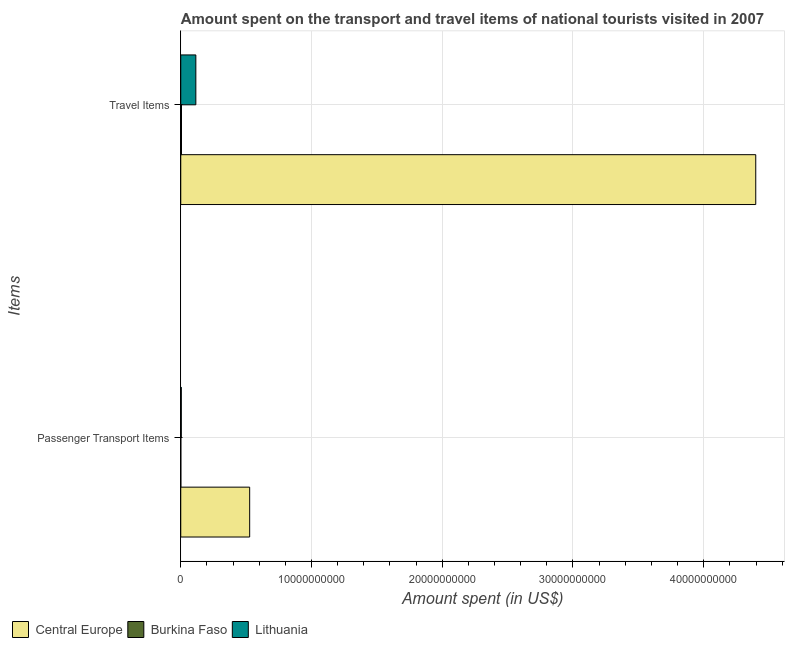How many different coloured bars are there?
Your answer should be very brief. 3. How many groups of bars are there?
Provide a succinct answer. 2. Are the number of bars per tick equal to the number of legend labels?
Provide a short and direct response. Yes. Are the number of bars on each tick of the Y-axis equal?
Make the answer very short. Yes. How many bars are there on the 1st tick from the top?
Offer a terse response. 3. How many bars are there on the 1st tick from the bottom?
Provide a succinct answer. 3. What is the label of the 2nd group of bars from the top?
Offer a terse response. Passenger Transport Items. What is the amount spent on passenger transport items in Burkina Faso?
Offer a terse response. 5.00e+06. Across all countries, what is the maximum amount spent in travel items?
Keep it short and to the point. 4.40e+1. Across all countries, what is the minimum amount spent on passenger transport items?
Ensure brevity in your answer.  5.00e+06. In which country was the amount spent in travel items maximum?
Your answer should be very brief. Central Europe. In which country was the amount spent in travel items minimum?
Provide a short and direct response. Burkina Faso. What is the total amount spent in travel items in the graph?
Your answer should be very brief. 4.52e+1. What is the difference between the amount spent on passenger transport items in Lithuania and that in Central Europe?
Offer a very short reply. -5.23e+09. What is the difference between the amount spent in travel items in Central Europe and the amount spent on passenger transport items in Burkina Faso?
Provide a succinct answer. 4.40e+1. What is the average amount spent in travel items per country?
Offer a very short reply. 1.51e+1. What is the difference between the amount spent in travel items and amount spent on passenger transport items in Lithuania?
Give a very brief answer. 1.11e+09. What is the ratio of the amount spent on passenger transport items in Burkina Faso to that in Central Europe?
Your response must be concise. 0. Is the amount spent in travel items in Lithuania less than that in Burkina Faso?
Offer a very short reply. No. In how many countries, is the amount spent on passenger transport items greater than the average amount spent on passenger transport items taken over all countries?
Keep it short and to the point. 1. What does the 2nd bar from the top in Travel Items represents?
Keep it short and to the point. Burkina Faso. What does the 1st bar from the bottom in Travel Items represents?
Give a very brief answer. Central Europe. How many bars are there?
Offer a terse response. 6. What is the difference between two consecutive major ticks on the X-axis?
Your answer should be compact. 1.00e+1. Are the values on the major ticks of X-axis written in scientific E-notation?
Your response must be concise. No. Does the graph contain any zero values?
Provide a short and direct response. No. Where does the legend appear in the graph?
Ensure brevity in your answer.  Bottom left. How many legend labels are there?
Provide a succinct answer. 3. How are the legend labels stacked?
Make the answer very short. Horizontal. What is the title of the graph?
Offer a terse response. Amount spent on the transport and travel items of national tourists visited in 2007. Does "Denmark" appear as one of the legend labels in the graph?
Provide a succinct answer. No. What is the label or title of the X-axis?
Your response must be concise. Amount spent (in US$). What is the label or title of the Y-axis?
Make the answer very short. Items. What is the Amount spent (in US$) of Central Europe in Passenger Transport Items?
Make the answer very short. 5.27e+09. What is the Amount spent (in US$) in Lithuania in Passenger Transport Items?
Your answer should be compact. 3.90e+07. What is the Amount spent (in US$) in Central Europe in Travel Items?
Give a very brief answer. 4.40e+1. What is the Amount spent (in US$) of Burkina Faso in Travel Items?
Keep it short and to the point. 5.60e+07. What is the Amount spent (in US$) of Lithuania in Travel Items?
Your answer should be compact. 1.15e+09. Across all Items, what is the maximum Amount spent (in US$) of Central Europe?
Offer a very short reply. 4.40e+1. Across all Items, what is the maximum Amount spent (in US$) in Burkina Faso?
Ensure brevity in your answer.  5.60e+07. Across all Items, what is the maximum Amount spent (in US$) of Lithuania?
Keep it short and to the point. 1.15e+09. Across all Items, what is the minimum Amount spent (in US$) in Central Europe?
Provide a short and direct response. 5.27e+09. Across all Items, what is the minimum Amount spent (in US$) of Lithuania?
Ensure brevity in your answer.  3.90e+07. What is the total Amount spent (in US$) in Central Europe in the graph?
Offer a terse response. 4.92e+1. What is the total Amount spent (in US$) in Burkina Faso in the graph?
Give a very brief answer. 6.10e+07. What is the total Amount spent (in US$) of Lithuania in the graph?
Make the answer very short. 1.19e+09. What is the difference between the Amount spent (in US$) in Central Europe in Passenger Transport Items and that in Travel Items?
Ensure brevity in your answer.  -3.87e+1. What is the difference between the Amount spent (in US$) of Burkina Faso in Passenger Transport Items and that in Travel Items?
Your answer should be compact. -5.10e+07. What is the difference between the Amount spent (in US$) of Lithuania in Passenger Transport Items and that in Travel Items?
Provide a short and direct response. -1.11e+09. What is the difference between the Amount spent (in US$) of Central Europe in Passenger Transport Items and the Amount spent (in US$) of Burkina Faso in Travel Items?
Your response must be concise. 5.22e+09. What is the difference between the Amount spent (in US$) in Central Europe in Passenger Transport Items and the Amount spent (in US$) in Lithuania in Travel Items?
Offer a very short reply. 4.12e+09. What is the difference between the Amount spent (in US$) of Burkina Faso in Passenger Transport Items and the Amount spent (in US$) of Lithuania in Travel Items?
Provide a succinct answer. -1.15e+09. What is the average Amount spent (in US$) in Central Europe per Items?
Ensure brevity in your answer.  2.46e+1. What is the average Amount spent (in US$) in Burkina Faso per Items?
Keep it short and to the point. 3.05e+07. What is the average Amount spent (in US$) of Lithuania per Items?
Give a very brief answer. 5.96e+08. What is the difference between the Amount spent (in US$) of Central Europe and Amount spent (in US$) of Burkina Faso in Passenger Transport Items?
Offer a terse response. 5.27e+09. What is the difference between the Amount spent (in US$) in Central Europe and Amount spent (in US$) in Lithuania in Passenger Transport Items?
Offer a very short reply. 5.23e+09. What is the difference between the Amount spent (in US$) in Burkina Faso and Amount spent (in US$) in Lithuania in Passenger Transport Items?
Keep it short and to the point. -3.40e+07. What is the difference between the Amount spent (in US$) of Central Europe and Amount spent (in US$) of Burkina Faso in Travel Items?
Your response must be concise. 4.39e+1. What is the difference between the Amount spent (in US$) in Central Europe and Amount spent (in US$) in Lithuania in Travel Items?
Your response must be concise. 4.28e+1. What is the difference between the Amount spent (in US$) in Burkina Faso and Amount spent (in US$) in Lithuania in Travel Items?
Provide a succinct answer. -1.10e+09. What is the ratio of the Amount spent (in US$) of Central Europe in Passenger Transport Items to that in Travel Items?
Your answer should be compact. 0.12. What is the ratio of the Amount spent (in US$) of Burkina Faso in Passenger Transport Items to that in Travel Items?
Ensure brevity in your answer.  0.09. What is the ratio of the Amount spent (in US$) in Lithuania in Passenger Transport Items to that in Travel Items?
Your response must be concise. 0.03. What is the difference between the highest and the second highest Amount spent (in US$) of Central Europe?
Provide a short and direct response. 3.87e+1. What is the difference between the highest and the second highest Amount spent (in US$) in Burkina Faso?
Offer a very short reply. 5.10e+07. What is the difference between the highest and the second highest Amount spent (in US$) in Lithuania?
Provide a succinct answer. 1.11e+09. What is the difference between the highest and the lowest Amount spent (in US$) in Central Europe?
Make the answer very short. 3.87e+1. What is the difference between the highest and the lowest Amount spent (in US$) in Burkina Faso?
Offer a terse response. 5.10e+07. What is the difference between the highest and the lowest Amount spent (in US$) in Lithuania?
Provide a short and direct response. 1.11e+09. 